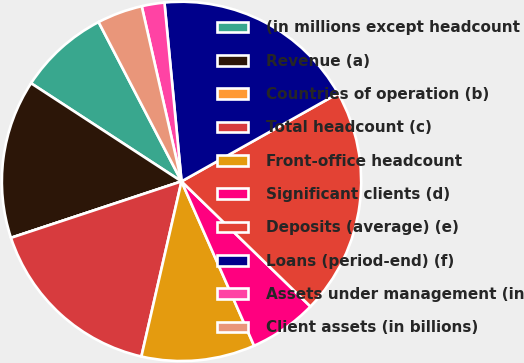Convert chart. <chart><loc_0><loc_0><loc_500><loc_500><pie_chart><fcel>(in millions except headcount<fcel>Revenue (a)<fcel>Countries of operation (b)<fcel>Total headcount (c)<fcel>Front-office headcount<fcel>Significant clients (d)<fcel>Deposits (average) (e)<fcel>Loans (period-end) (f)<fcel>Assets under management (in<fcel>Client assets (in billions)<nl><fcel>8.16%<fcel>14.28%<fcel>0.0%<fcel>16.32%<fcel>10.2%<fcel>6.12%<fcel>20.4%<fcel>18.36%<fcel>2.04%<fcel>4.08%<nl></chart> 